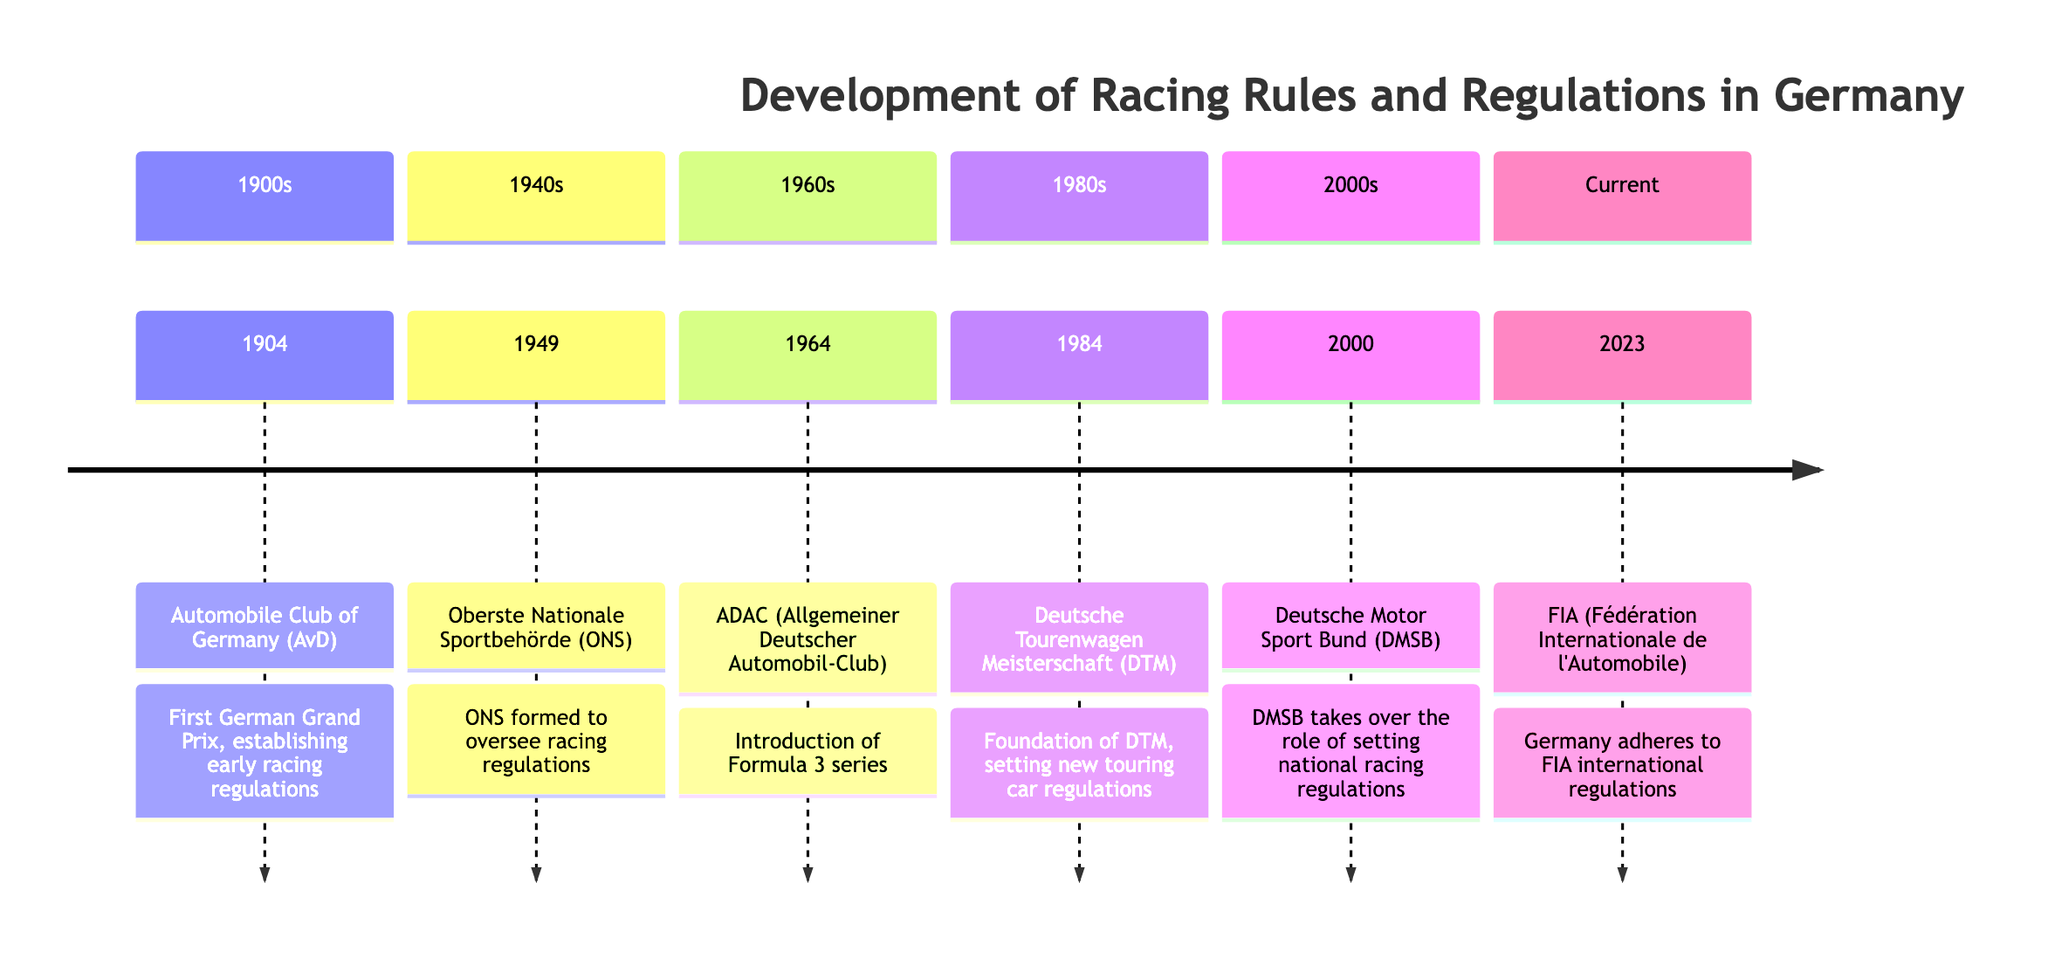What organization was involved in the 1904 event? The 1904 event is associated with the Automobile Club of Germany (AvD), as stated in the section for the 1900s.
Answer: Automobile Club of Germany (AvD) What year was the first German Grand Prix held? The diagram indicates that the first German Grand Prix was held in 1904, with a specific mention in the key events under the 1900s section.
Answer: 1904 Which organization formed in 1949? The diagram specifies that the Oberste Nationale Sportbehörde (ONS) was formed in 1949 to oversee racing regulations, mentioned in the 1940s section.
Answer: Oberste Nationale Sportbehörde (ONS) How many organizations are listed from the 1980s onward? Counting the organizations listed from the 1980s to the Current section, there are three: Deutsche Tourenwagen Meisterschaft (DTM), Deutsche Motor Sport Bund (DMSB), and FIA.
Answer: 3 What was established in 1964? According to the diagram, the introduction of the Formula 3 series is the key event listed in the 1960s section for the year 1964.
Answer: Introduction of Formula 3 series Which event led to a change in racing regulations in Germany in 2000? The key event for the year 2000 mentions that the Deutsche Motor Sport Bund (DMSB) took over the role of setting national racing regulations, indicating a significant regulatory change.
Answer: DMSB takes over What does FIA stand for? In the Current section, the abbreviation FIA is specified as standing for Fédération Internationale de l'Automobile.
Answer: Fédération Internationale de l'Automobile Which decade marks the foundation of DTM? The foundation of the Deutsche Tourenwagen Meisterschaft (DTM) is noted in the 1980s section with the key event occurring in 1984.
Answer: 1980s What event does Germany adhere to in 2023? The diagram states that in 2023, Germany adheres to FIA international regulations, which is a significant event listed in the Current section.
Answer: FIA international regulations 